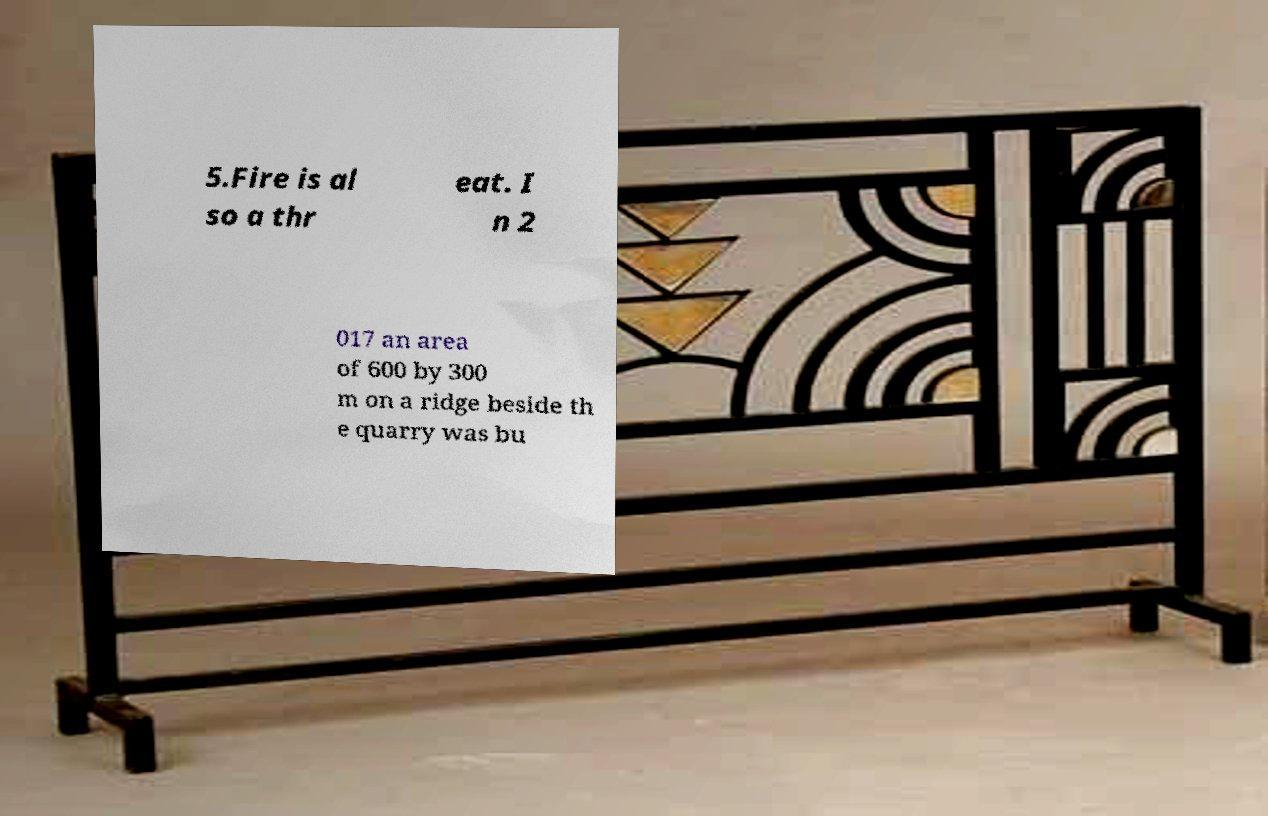Can you accurately transcribe the text from the provided image for me? 5.Fire is al so a thr eat. I n 2 017 an area of 600 by 300 m on a ridge beside th e quarry was bu 